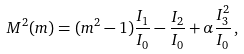<formula> <loc_0><loc_0><loc_500><loc_500>M ^ { 2 } ( m ) = ( m ^ { 2 } - 1 ) \frac { I _ { 1 } } { I _ { 0 } } - \frac { I _ { 2 } } { I _ { 0 } } + \alpha \frac { I _ { 3 } ^ { 2 } } { I _ { 0 } } \, ,</formula> 